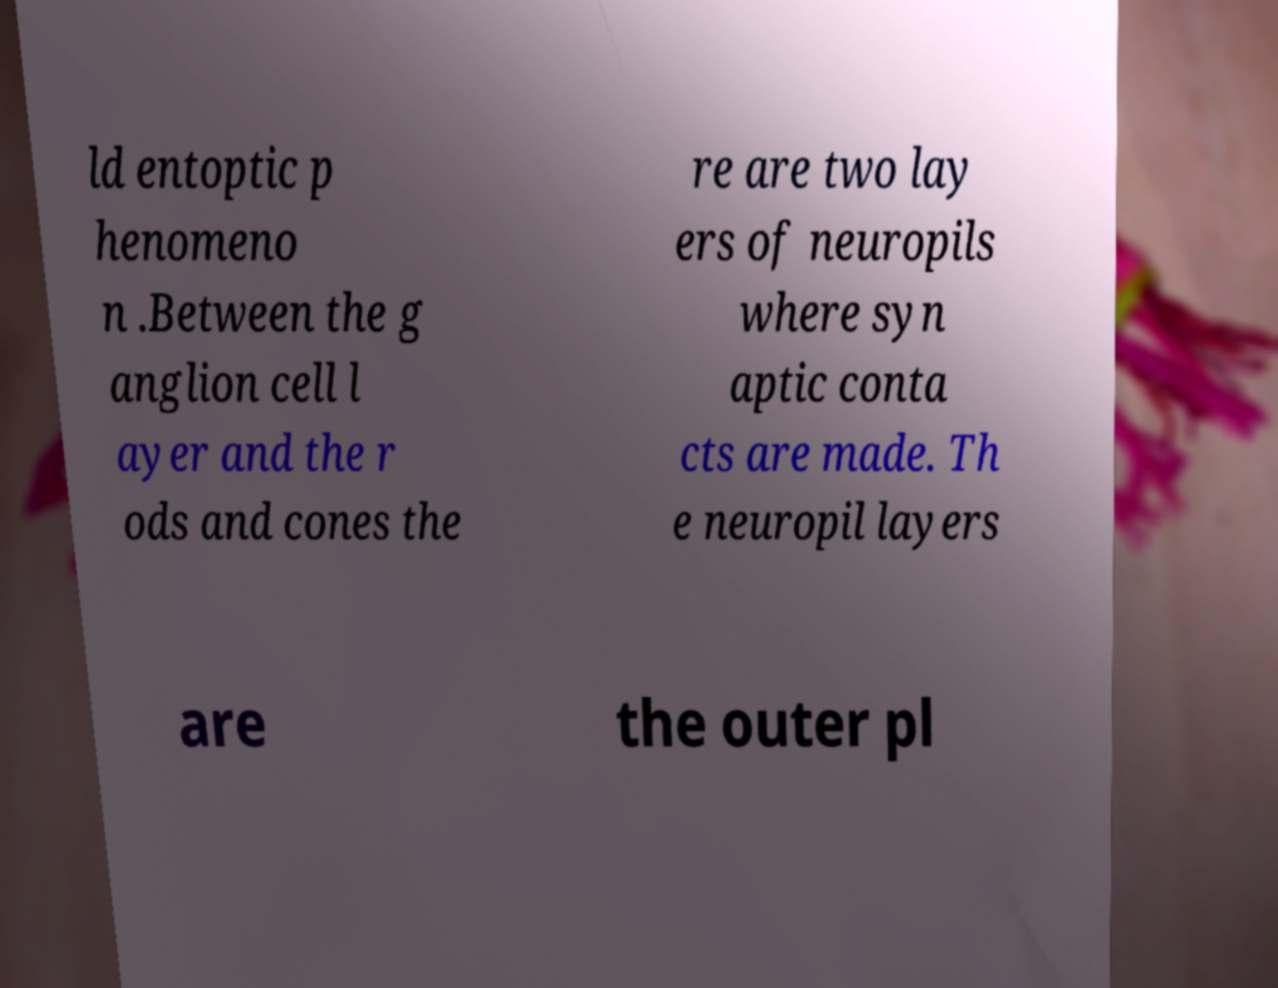There's text embedded in this image that I need extracted. Can you transcribe it verbatim? ld entoptic p henomeno n .Between the g anglion cell l ayer and the r ods and cones the re are two lay ers of neuropils where syn aptic conta cts are made. Th e neuropil layers are the outer pl 